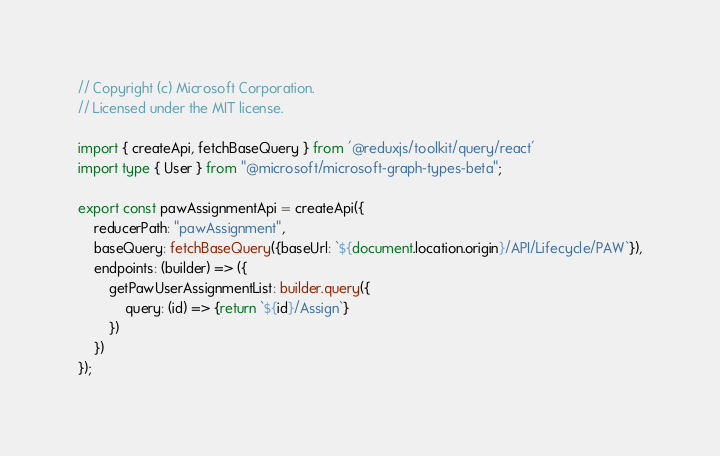<code> <loc_0><loc_0><loc_500><loc_500><_TypeScript_>// Copyright (c) Microsoft Corporation.
// Licensed under the MIT license.

import { createApi, fetchBaseQuery } from '@reduxjs/toolkit/query/react'
import type { User } from "@microsoft/microsoft-graph-types-beta";

export const pawAssignmentApi = createApi({
    reducerPath: "pawAssignment",
    baseQuery: fetchBaseQuery({baseUrl: `${document.location.origin}/API/Lifecycle/PAW`}),
    endpoints: (builder) => ({
        getPawUserAssignmentList: builder.query({
            query: (id) => {return `${id}/Assign`}
        })
    })
});</code> 